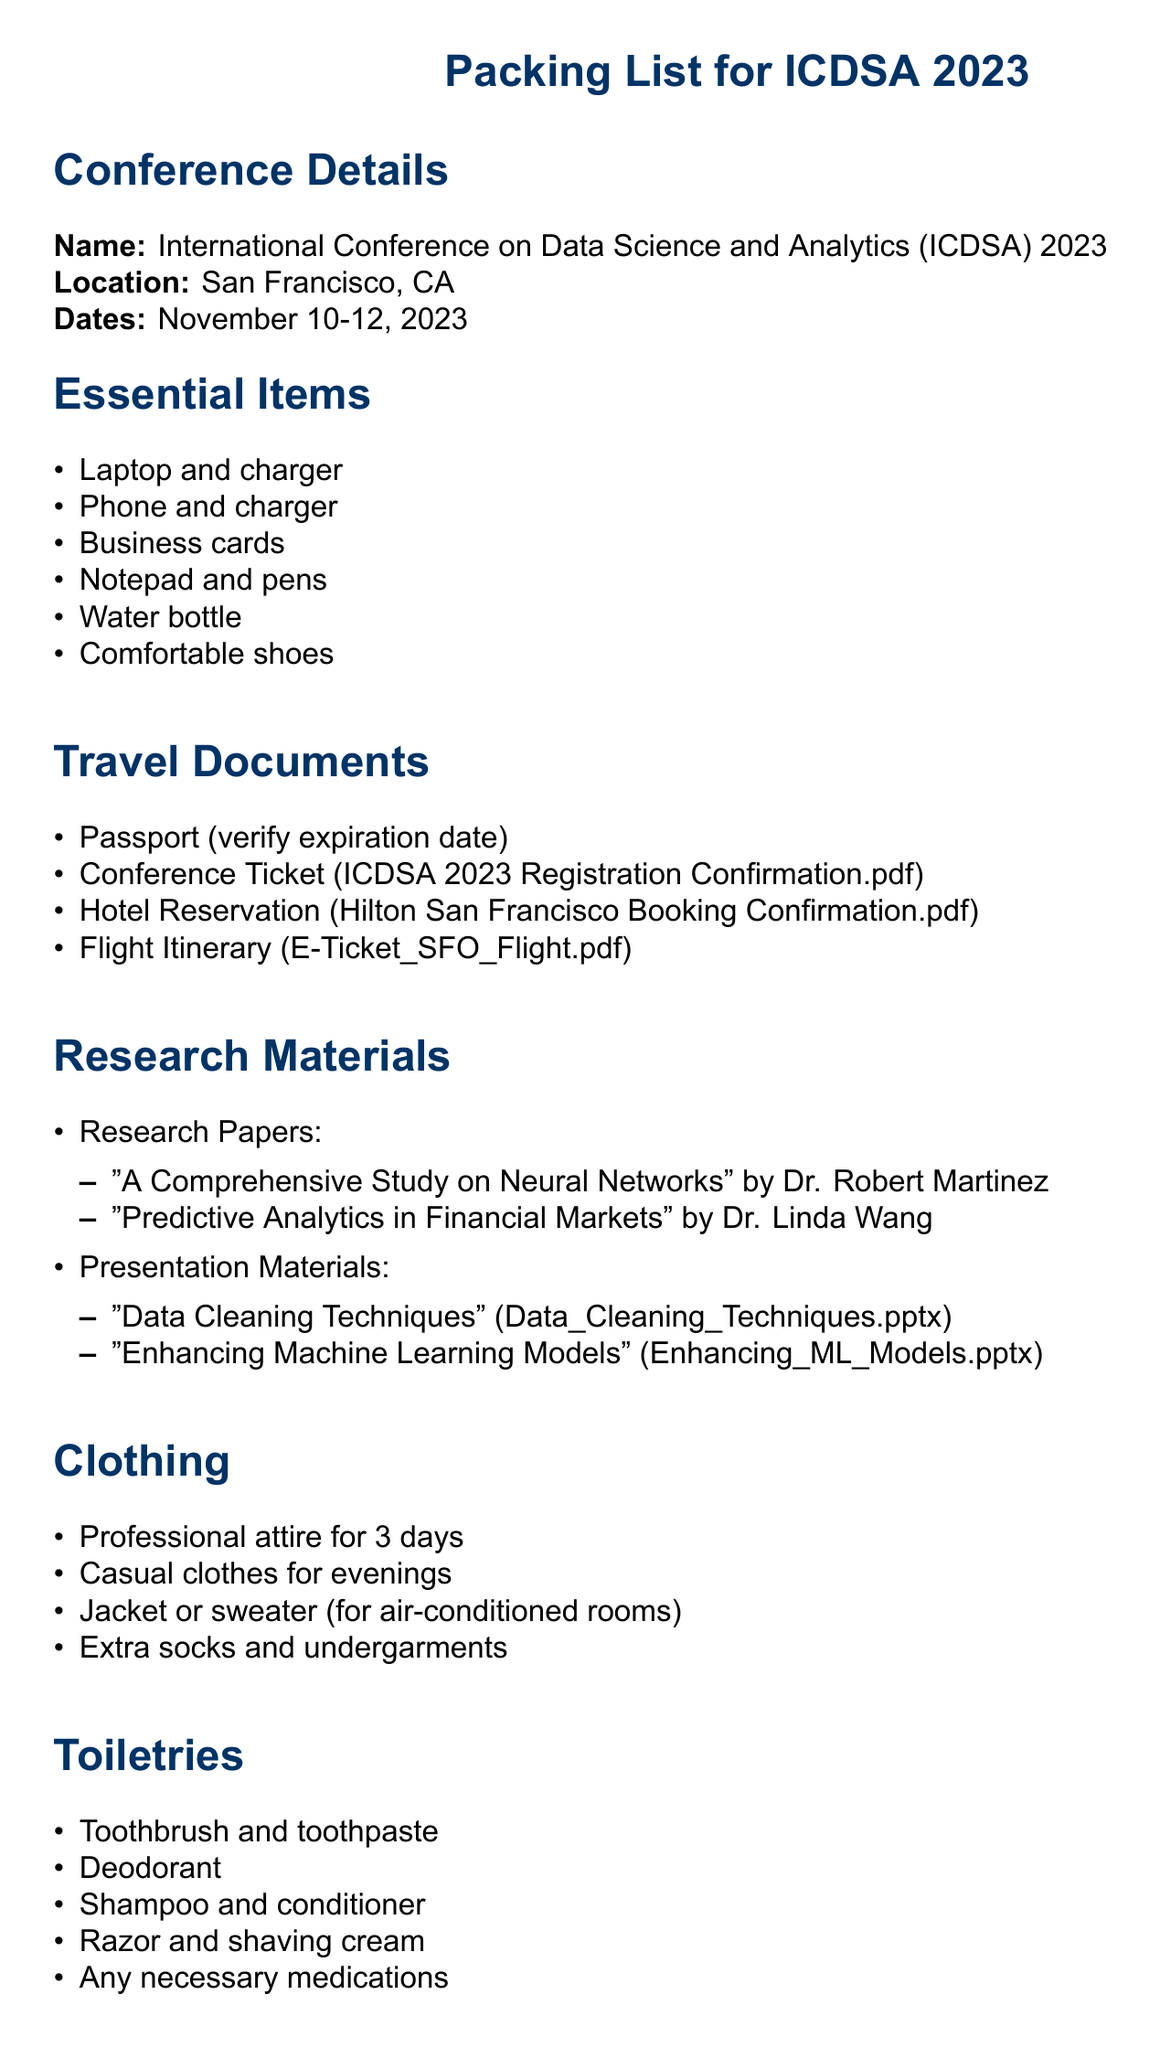What is the conference name? The conference name is stated at the beginning of the document as "International Conference on Data Science and Analytics (ICDSA) 2023".
Answer: International Conference on Data Science and Analytics (ICDSA) 2023 What are the conference dates? The document specifies the conference dates as "November 10-12, 2023".
Answer: November 10-12, 2023 How many research papers are listed in the document? The document lists two research papers under the Research Materials section, indicating the quantity directly.
Answer: 2 What type of attire is recommended for the conference? The document mentions "Professional attire for 3 days" under the Clothing section which indicates the type of clothing required.
Answer: Professional attire Which travel document confirms the hotel reservation? The document refers to "Hilton San Francisco Booking Confirmation.pdf" in the Travel Documents section.
Answer: Hilton San Francisco Booking Confirmation.pdf What is one of the listed essential items for the conference? The document includes "Laptop and charger" in the Essential Items section, which is an example of necessary items.
Answer: Laptop and charger How many presentation materials are included? There are two items listed under presentation materials in the Research Materials section of the document.
Answer: 2 What is advised to be packed for technology? The document specifies "Portable power bank" as one of the technology items that should be packed.
Answer: Portable power bank Why should attendees review the conference agenda? The document suggests attendees review the agenda to prepare questions for sessions, which relates to effective conference participation.
Answer: Prepare questions for specific sessions 